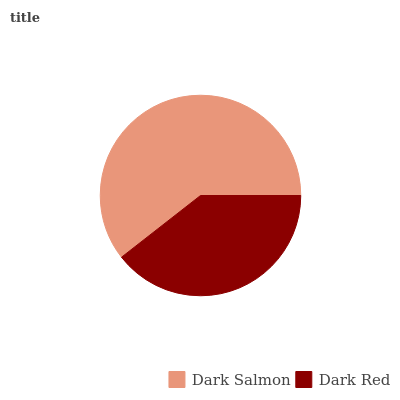Is Dark Red the minimum?
Answer yes or no. Yes. Is Dark Salmon the maximum?
Answer yes or no. Yes. Is Dark Red the maximum?
Answer yes or no. No. Is Dark Salmon greater than Dark Red?
Answer yes or no. Yes. Is Dark Red less than Dark Salmon?
Answer yes or no. Yes. Is Dark Red greater than Dark Salmon?
Answer yes or no. No. Is Dark Salmon less than Dark Red?
Answer yes or no. No. Is Dark Salmon the high median?
Answer yes or no. Yes. Is Dark Red the low median?
Answer yes or no. Yes. Is Dark Red the high median?
Answer yes or no. No. Is Dark Salmon the low median?
Answer yes or no. No. 